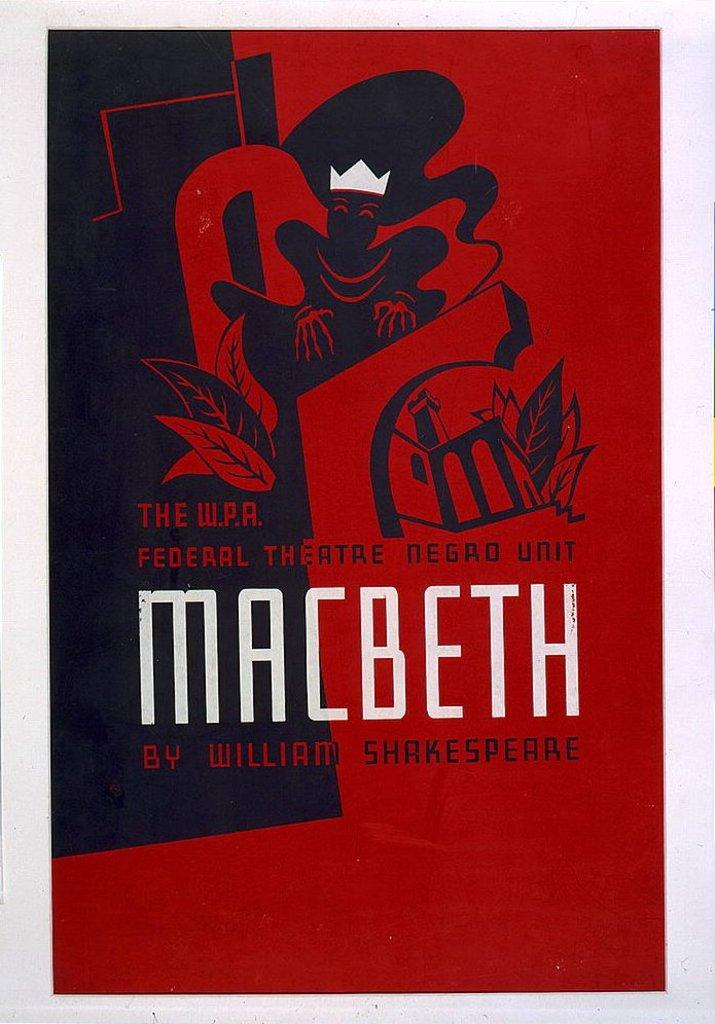What is the color of the poster in the image? The poster is red. What can be found on the poster besides the color? The poster contains pictures and text. How many coasts are depicted on the poster? There is no coast depicted on the poster; it contains pictures and text. What type of pleasure can be seen being enjoyed by the people in the poster? There are no people depicted in the poster, and therefore no pleasure can be observed. 